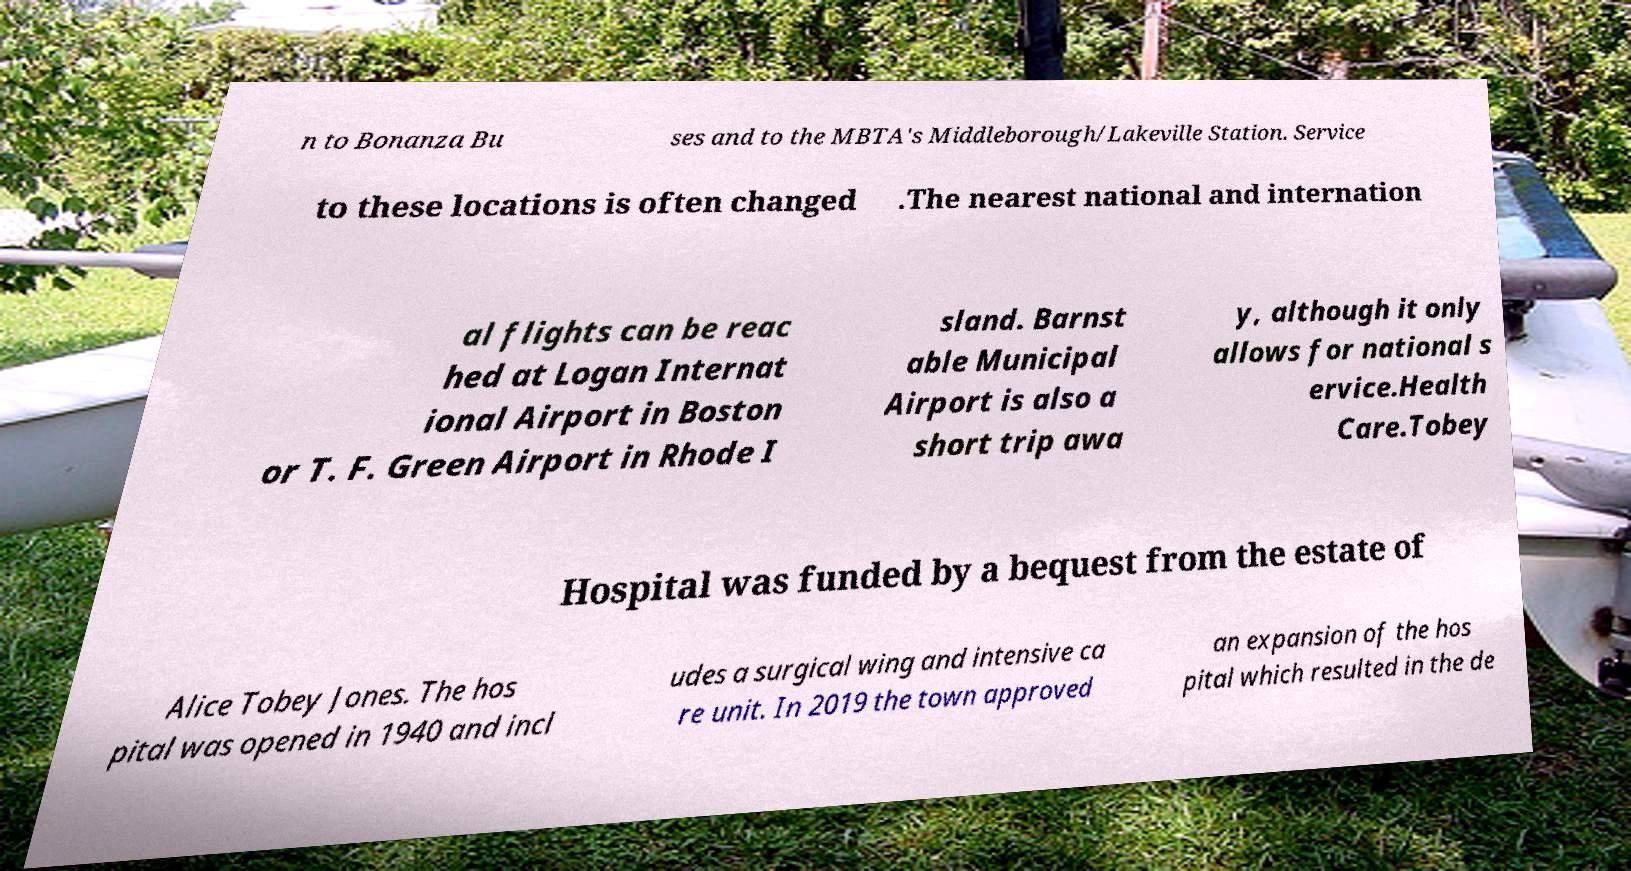Could you extract and type out the text from this image? n to Bonanza Bu ses and to the MBTA's Middleborough/Lakeville Station. Service to these locations is often changed .The nearest national and internation al flights can be reac hed at Logan Internat ional Airport in Boston or T. F. Green Airport in Rhode I sland. Barnst able Municipal Airport is also a short trip awa y, although it only allows for national s ervice.Health Care.Tobey Hospital was funded by a bequest from the estate of Alice Tobey Jones. The hos pital was opened in 1940 and incl udes a surgical wing and intensive ca re unit. In 2019 the town approved an expansion of the hos pital which resulted in the de 